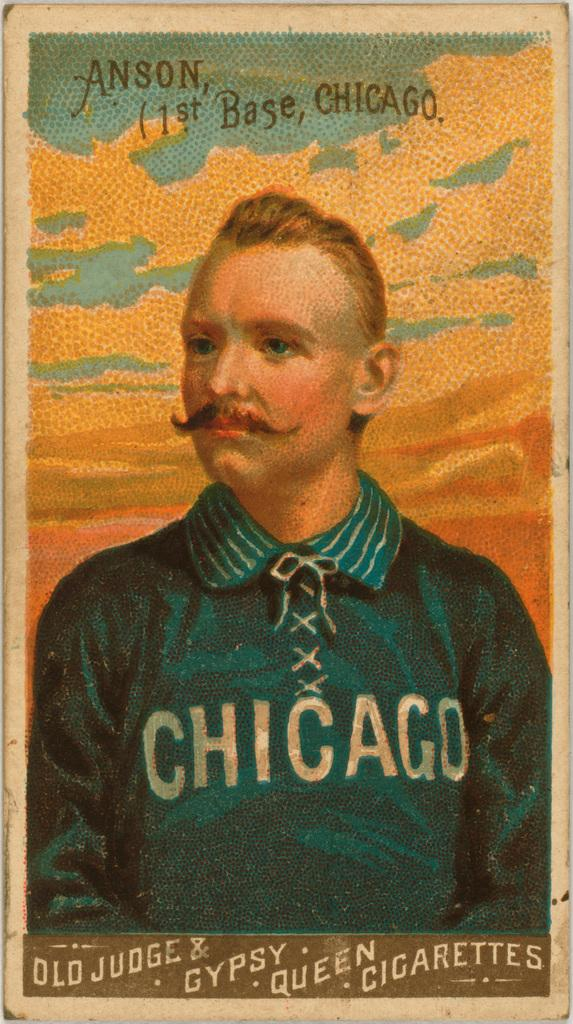<image>
Render a clear and concise summary of the photo. Drawing of a person wearing a Chicago shirt and the name Anson on top. 